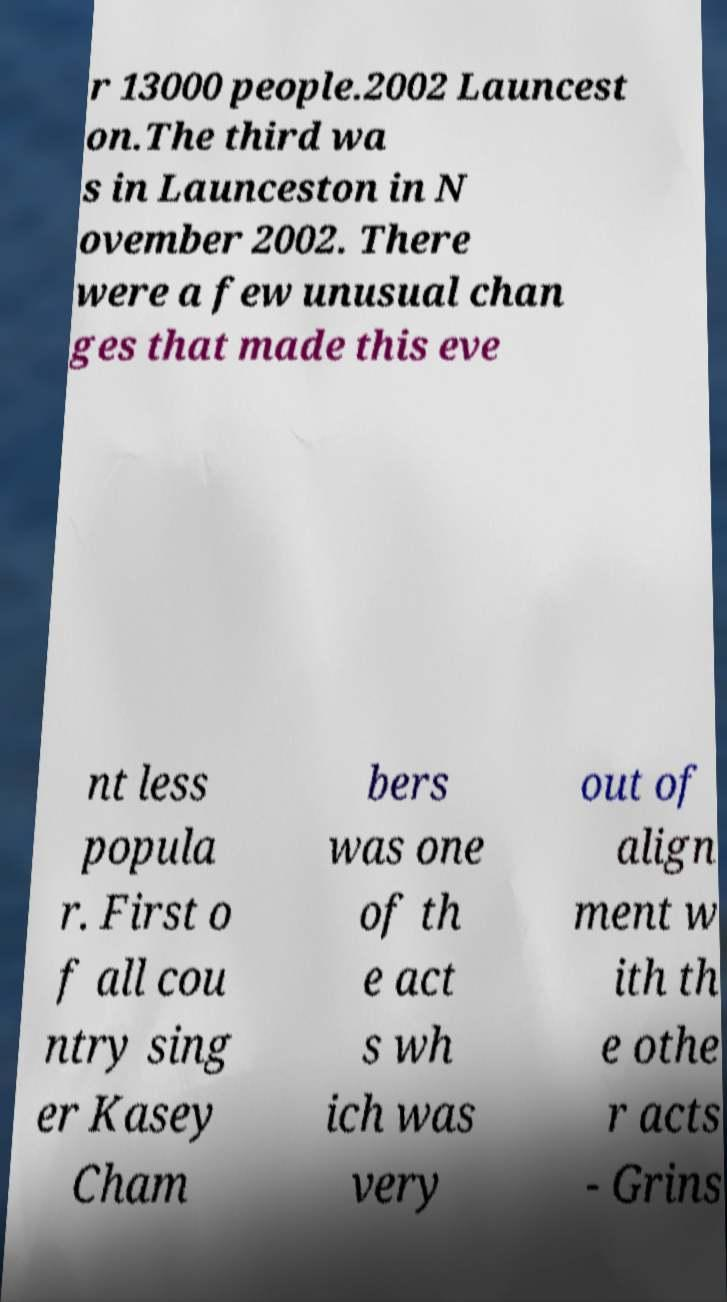Could you extract and type out the text from this image? r 13000 people.2002 Launcest on.The third wa s in Launceston in N ovember 2002. There were a few unusual chan ges that made this eve nt less popula r. First o f all cou ntry sing er Kasey Cham bers was one of th e act s wh ich was very out of align ment w ith th e othe r acts - Grins 